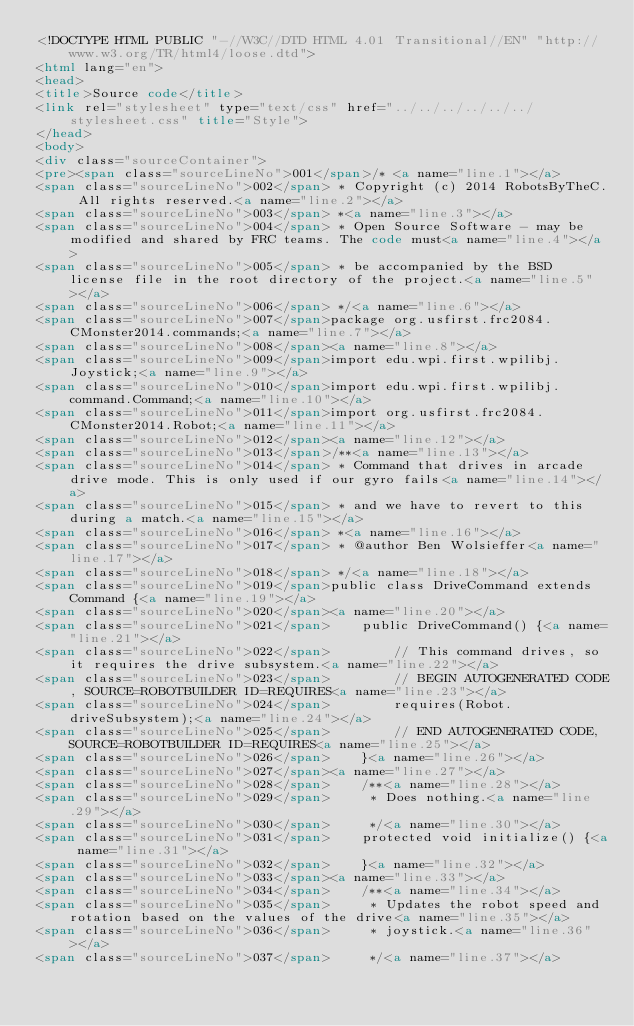Convert code to text. <code><loc_0><loc_0><loc_500><loc_500><_HTML_><!DOCTYPE HTML PUBLIC "-//W3C//DTD HTML 4.01 Transitional//EN" "http://www.w3.org/TR/html4/loose.dtd">
<html lang="en">
<head>
<title>Source code</title>
<link rel="stylesheet" type="text/css" href="../../../../../../stylesheet.css" title="Style">
</head>
<body>
<div class="sourceContainer">
<pre><span class="sourceLineNo">001</span>/* <a name="line.1"></a>
<span class="sourceLineNo">002</span> * Copyright (c) 2014 RobotsByTheC. All rights reserved.<a name="line.2"></a>
<span class="sourceLineNo">003</span> *<a name="line.3"></a>
<span class="sourceLineNo">004</span> * Open Source Software - may be modified and shared by FRC teams. The code must<a name="line.4"></a>
<span class="sourceLineNo">005</span> * be accompanied by the BSD license file in the root directory of the project.<a name="line.5"></a>
<span class="sourceLineNo">006</span> */<a name="line.6"></a>
<span class="sourceLineNo">007</span>package org.usfirst.frc2084.CMonster2014.commands;<a name="line.7"></a>
<span class="sourceLineNo">008</span><a name="line.8"></a>
<span class="sourceLineNo">009</span>import edu.wpi.first.wpilibj.Joystick;<a name="line.9"></a>
<span class="sourceLineNo">010</span>import edu.wpi.first.wpilibj.command.Command;<a name="line.10"></a>
<span class="sourceLineNo">011</span>import org.usfirst.frc2084.CMonster2014.Robot;<a name="line.11"></a>
<span class="sourceLineNo">012</span><a name="line.12"></a>
<span class="sourceLineNo">013</span>/**<a name="line.13"></a>
<span class="sourceLineNo">014</span> * Command that drives in arcade drive mode. This is only used if our gyro fails<a name="line.14"></a>
<span class="sourceLineNo">015</span> * and we have to revert to this during a match.<a name="line.15"></a>
<span class="sourceLineNo">016</span> *<a name="line.16"></a>
<span class="sourceLineNo">017</span> * @author Ben Wolsieffer<a name="line.17"></a>
<span class="sourceLineNo">018</span> */<a name="line.18"></a>
<span class="sourceLineNo">019</span>public class DriveCommand extends Command {<a name="line.19"></a>
<span class="sourceLineNo">020</span><a name="line.20"></a>
<span class="sourceLineNo">021</span>    public DriveCommand() {<a name="line.21"></a>
<span class="sourceLineNo">022</span>        // This command drives, so it requires the drive subsystem.<a name="line.22"></a>
<span class="sourceLineNo">023</span>        // BEGIN AUTOGENERATED CODE, SOURCE=ROBOTBUILDER ID=REQUIRES<a name="line.23"></a>
<span class="sourceLineNo">024</span>        requires(Robot.driveSubsystem);<a name="line.24"></a>
<span class="sourceLineNo">025</span>        // END AUTOGENERATED CODE, SOURCE=ROBOTBUILDER ID=REQUIRES<a name="line.25"></a>
<span class="sourceLineNo">026</span>    }<a name="line.26"></a>
<span class="sourceLineNo">027</span><a name="line.27"></a>
<span class="sourceLineNo">028</span>    /**<a name="line.28"></a>
<span class="sourceLineNo">029</span>     * Does nothing.<a name="line.29"></a>
<span class="sourceLineNo">030</span>     */<a name="line.30"></a>
<span class="sourceLineNo">031</span>    protected void initialize() {<a name="line.31"></a>
<span class="sourceLineNo">032</span>    }<a name="line.32"></a>
<span class="sourceLineNo">033</span><a name="line.33"></a>
<span class="sourceLineNo">034</span>    /**<a name="line.34"></a>
<span class="sourceLineNo">035</span>     * Updates the robot speed and rotation based on the values of the drive<a name="line.35"></a>
<span class="sourceLineNo">036</span>     * joystick.<a name="line.36"></a>
<span class="sourceLineNo">037</span>     */<a name="line.37"></a></code> 